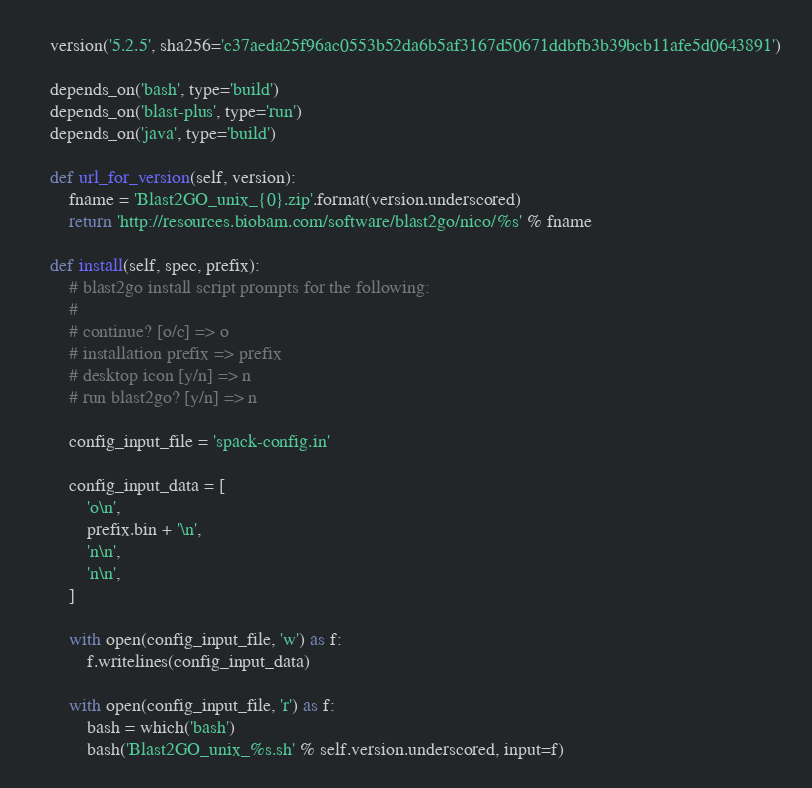Convert code to text. <code><loc_0><loc_0><loc_500><loc_500><_Python_>
    version('5.2.5', sha256='c37aeda25f96ac0553b52da6b5af3167d50671ddbfb3b39bcb11afe5d0643891')

    depends_on('bash', type='build')
    depends_on('blast-plus', type='run')
    depends_on('java', type='build')

    def url_for_version(self, version):
        fname = 'Blast2GO_unix_{0}.zip'.format(version.underscored)
        return 'http://resources.biobam.com/software/blast2go/nico/%s' % fname

    def install(self, spec, prefix):
        # blast2go install script prompts for the following:
        #
        # continue? [o/c] => o
        # installation prefix => prefix
        # desktop icon [y/n] => n
        # run blast2go? [y/n] => n

        config_input_file = 'spack-config.in'

        config_input_data = [
            'o\n',
            prefix.bin + '\n',
            'n\n',
            'n\n',
        ]

        with open(config_input_file, 'w') as f:
            f.writelines(config_input_data)

        with open(config_input_file, 'r') as f:
            bash = which('bash')
            bash('Blast2GO_unix_%s.sh' % self.version.underscored, input=f)
</code> 